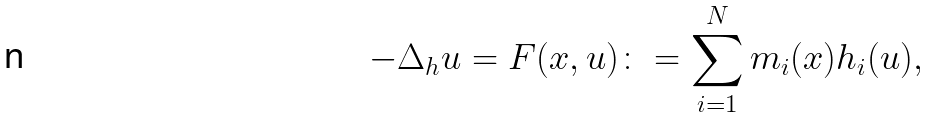<formula> <loc_0><loc_0><loc_500><loc_500>- \Delta _ { h } u = F ( x , u ) \colon = \sum _ { i = 1 } ^ { N } m _ { i } ( x ) h _ { i } ( u ) ,</formula> 